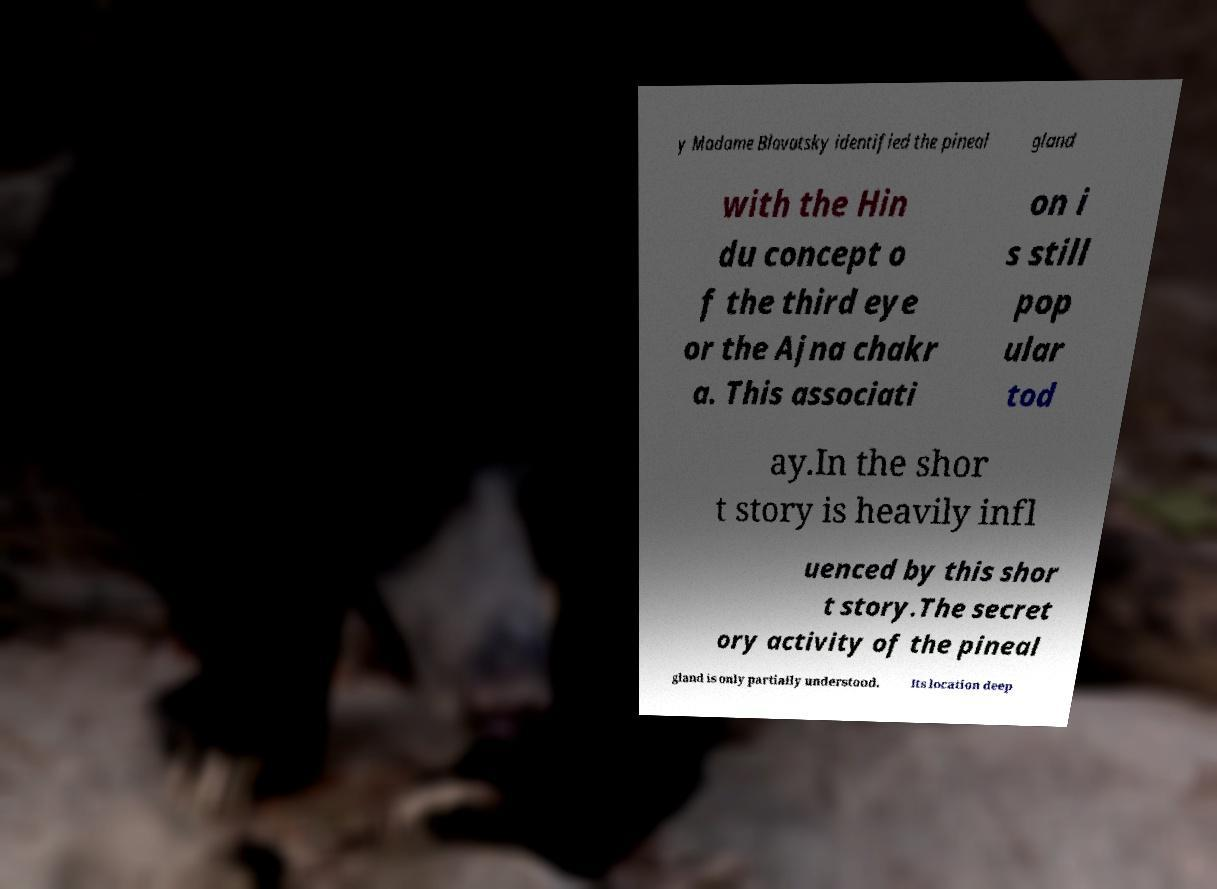Please identify and transcribe the text found in this image. y Madame Blavatsky identified the pineal gland with the Hin du concept o f the third eye or the Ajna chakr a. This associati on i s still pop ular tod ay.In the shor t story is heavily infl uenced by this shor t story.The secret ory activity of the pineal gland is only partially understood. Its location deep 